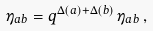<formula> <loc_0><loc_0><loc_500><loc_500>\eta _ { a b } = q ^ { \Delta ( a ) + \Delta ( b ) } \, \eta _ { a b } \, ,</formula> 